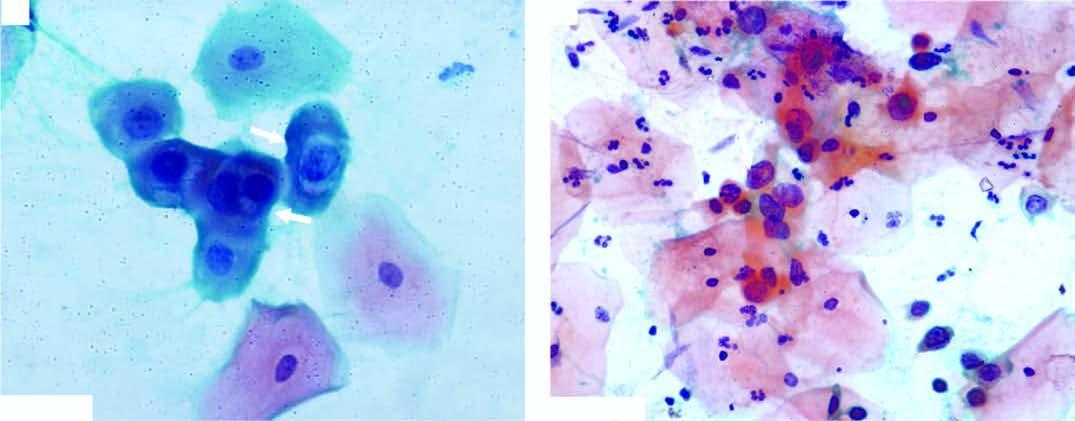what does the background show?
Answer the question using a single word or phrase. Pmns 